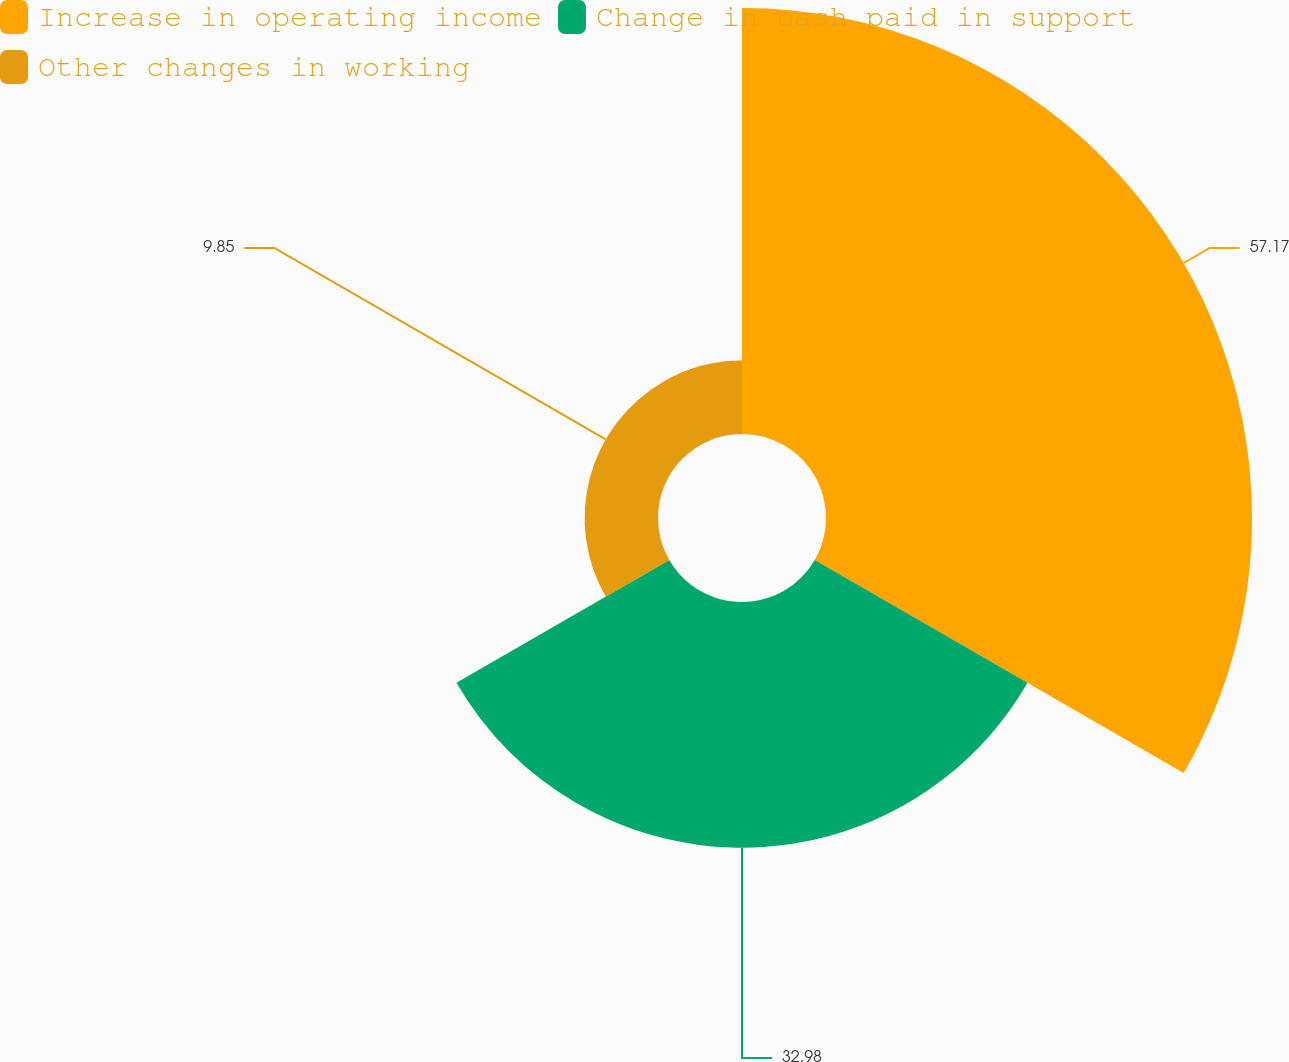<chart> <loc_0><loc_0><loc_500><loc_500><pie_chart><fcel>Increase in operating income<fcel>Change in cash paid in support<fcel>Other changes in working<nl><fcel>57.18%<fcel>32.98%<fcel>9.85%<nl></chart> 